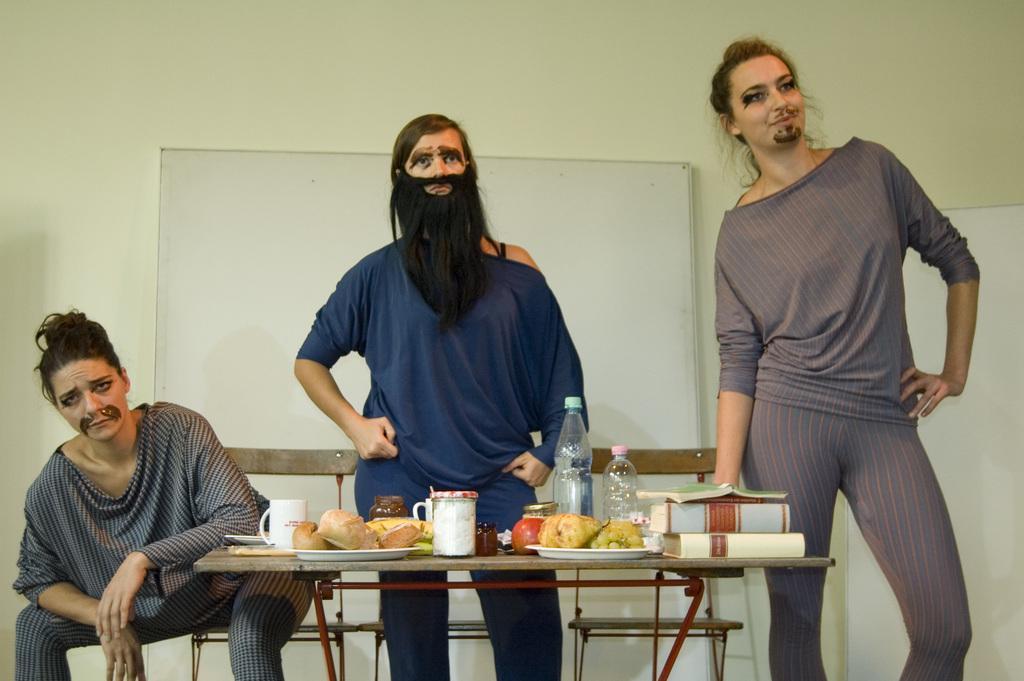Could you give a brief overview of what you see in this image? In the picture I can see three women where two among them are standing and the remaining one is sitting and there is a table in front of them which has few eatables and some other objects placed on it and there is a white board attached to the wall in the background. 